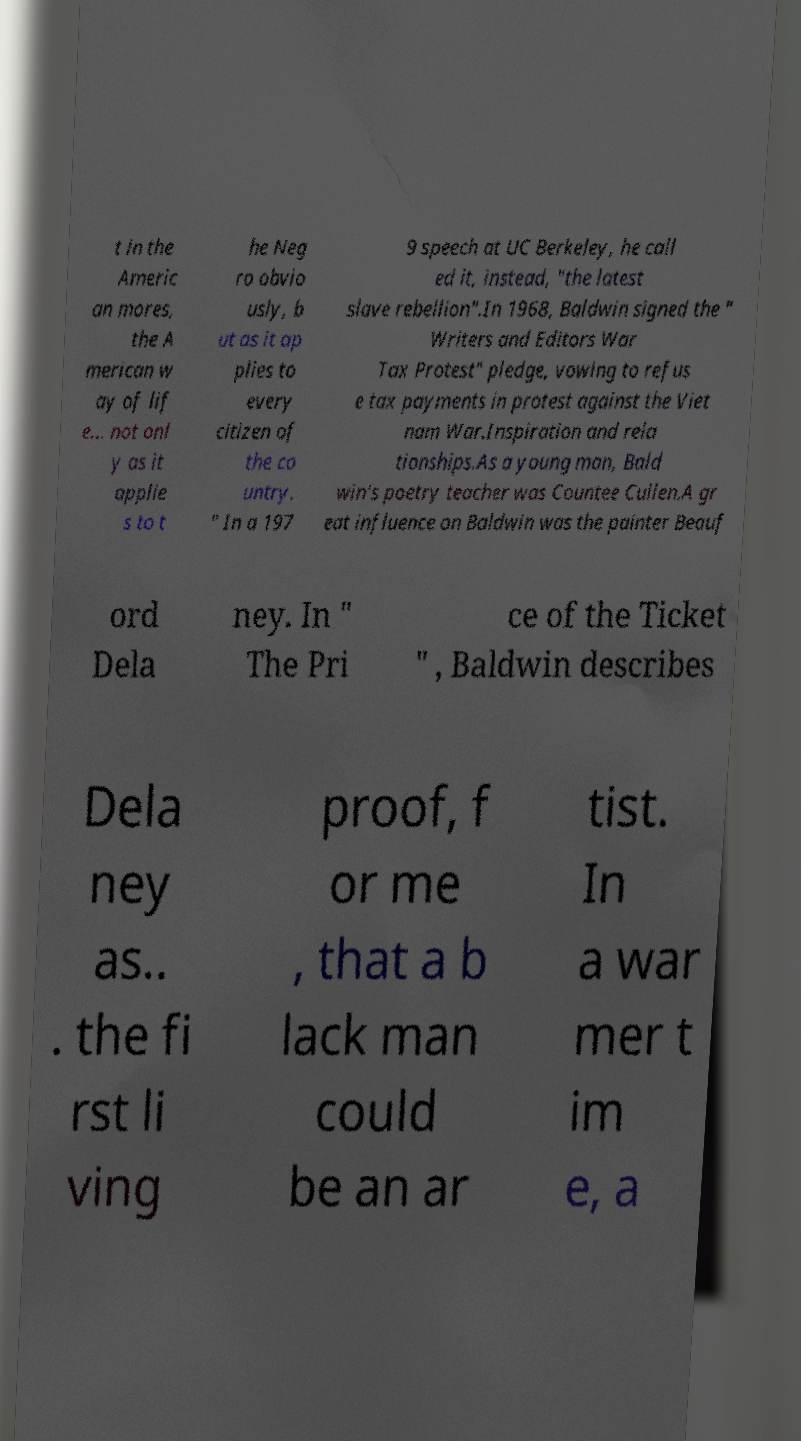There's text embedded in this image that I need extracted. Can you transcribe it verbatim? t in the Americ an mores, the A merican w ay of lif e... not onl y as it applie s to t he Neg ro obvio usly, b ut as it ap plies to every citizen of the co untry. " In a 197 9 speech at UC Berkeley, he call ed it, instead, "the latest slave rebellion".In 1968, Baldwin signed the " Writers and Editors War Tax Protest" pledge, vowing to refus e tax payments in protest against the Viet nam War.Inspiration and rela tionships.As a young man, Bald win's poetry teacher was Countee Cullen.A gr eat influence on Baldwin was the painter Beauf ord Dela ney. In " The Pri ce of the Ticket " , Baldwin describes Dela ney as.. . the fi rst li ving proof, f or me , that a b lack man could be an ar tist. In a war mer t im e, a 